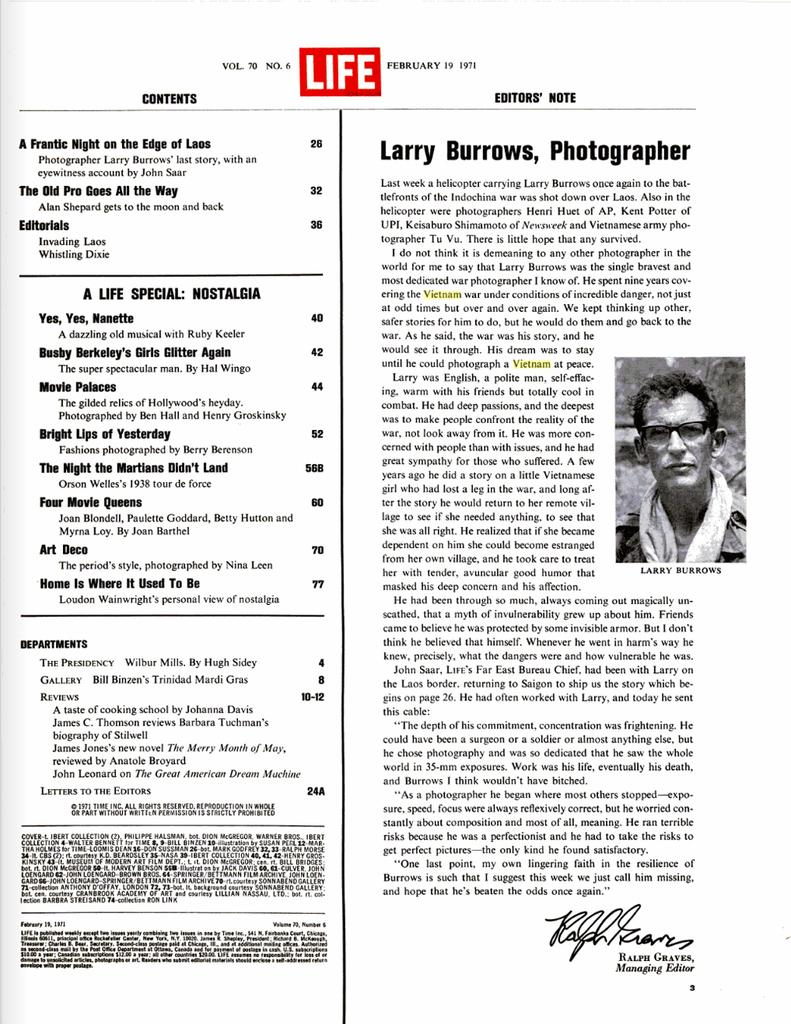What is the main subject in the center of the image? There is a poster in the center of the image. What is depicted on the poster? The poster features a person wearing glasses. Are there any words on the poster? Yes, there is text on the poster. What type of wool is being used to make the minister's hat in the image? There is no minister or hat present in the image; it features a poster with a person wearing glasses and text. How many teeth can be seen in the image? There are no teeth visible in the image. 